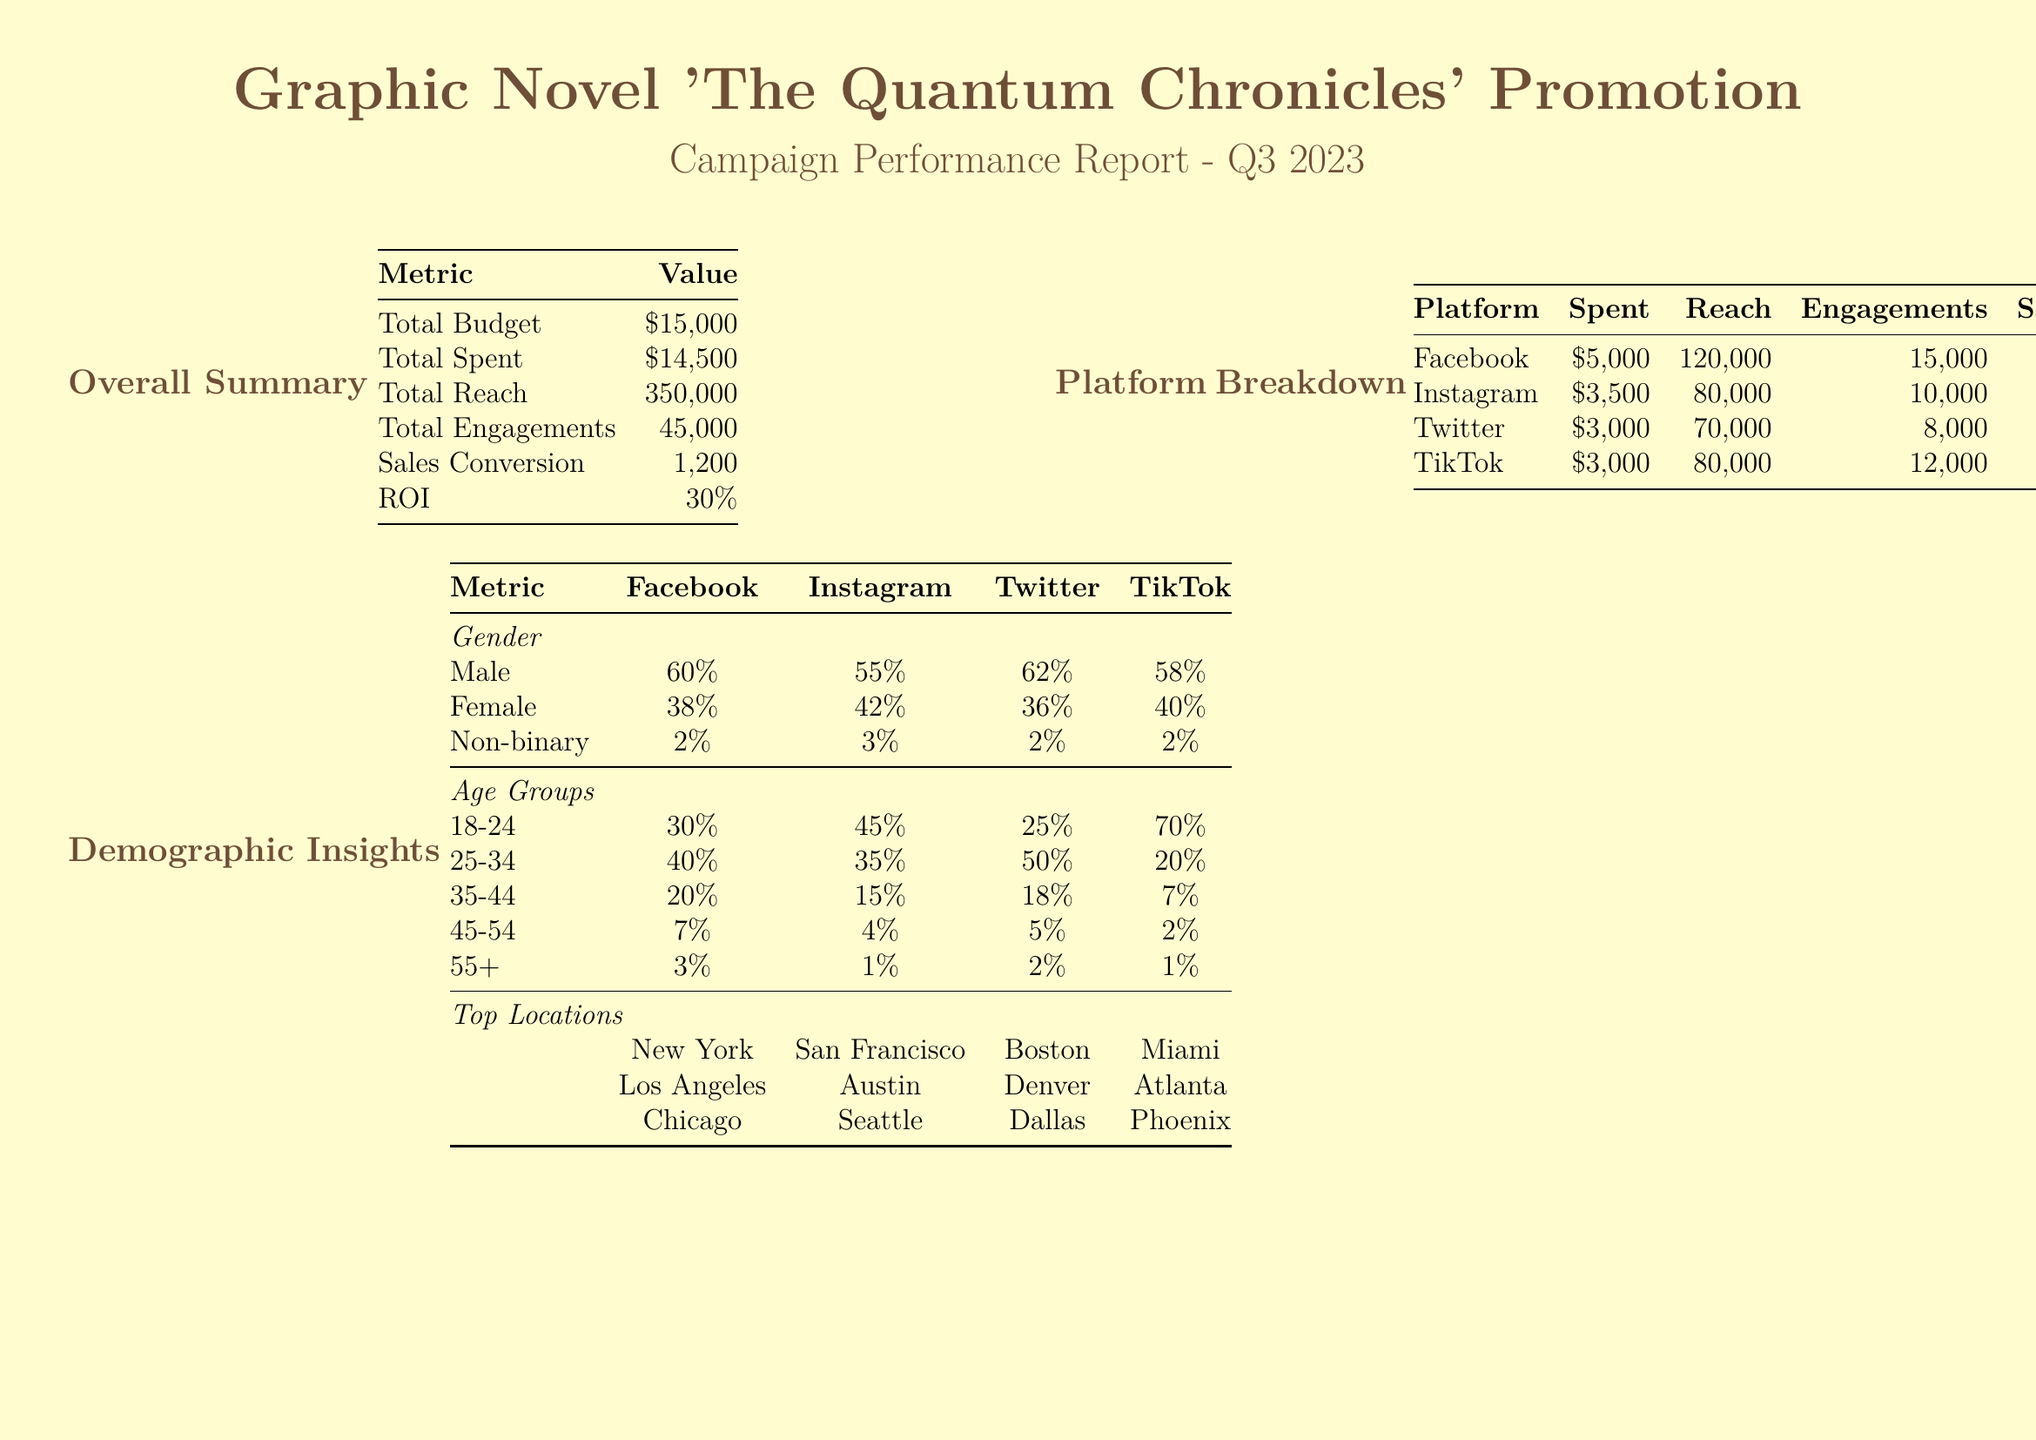What is the total budget for the campaign? The total budget is provided in the document under the "Overall Summary" section.
Answer: $15,000 What is the total engage ments for the campaign? The total engagements are listed in the Overall Summary, indicating the number of interactions.
Answer: 45,000 Which platform had the highest reach? The platform breakdown shows the reach for each platform, with Facebook leading.
Answer: Facebook What percentage of the Instagram audience is male? The demographic insights specify the gender distribution, highlighting the male percentage on Instagram.
Answer: 55% What is the sales conversion for the campaign? This metric is included in the Overall Summary section of the document for reference.
Answer: 1,200 Which platform shows the lowest sales conversion? Analyzing the sales data across platforms reveals which had the least success in conversions.
Answer: TikTok What is the age group with the highest presence on TikTok? The document includes age group statistics, highlighting which demographic dominates TikTok.
Answer: 18-24 How much money was spent on Twitter advertisements? The details of advertising expenditures are outlined in the Platform Breakdown table.
Answer: $3,000 What is the primary conclusion from the campaign report? The conclusion from the report summarizes the overall success and areas of improvement for the campaign.
Answer: Significant engagement 